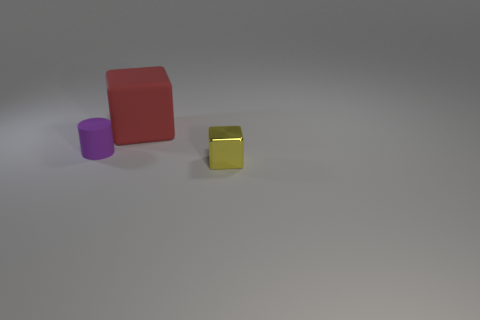Can you tell me which objects in the image are closest to the camera? The yellow metal cube is the closest object to the camera. What can you say about the lighting condition in the image? The lighting in the image appears to be soft and diffused, likely from an overhead source, given the gentle shadows cast by the objects. 